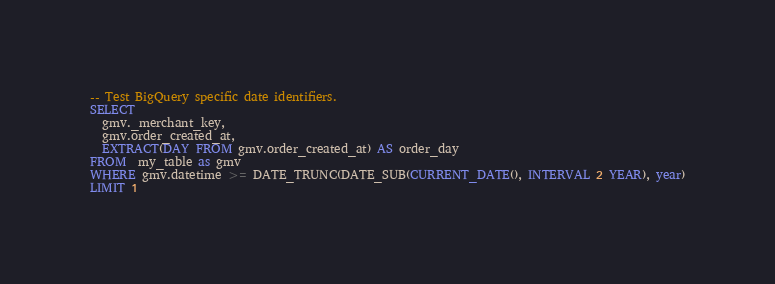<code> <loc_0><loc_0><loc_500><loc_500><_SQL_>-- Test BigQuery specific date identifiers.
SELECT
  gmv._merchant_key,
  gmv.order_created_at,
  EXTRACT(DAY FROM gmv.order_created_at) AS order_day
FROM  my_table as gmv
WHERE gmv.datetime >= DATE_TRUNC(DATE_SUB(CURRENT_DATE(), INTERVAL 2 YEAR), year)
LIMIT 1
</code> 